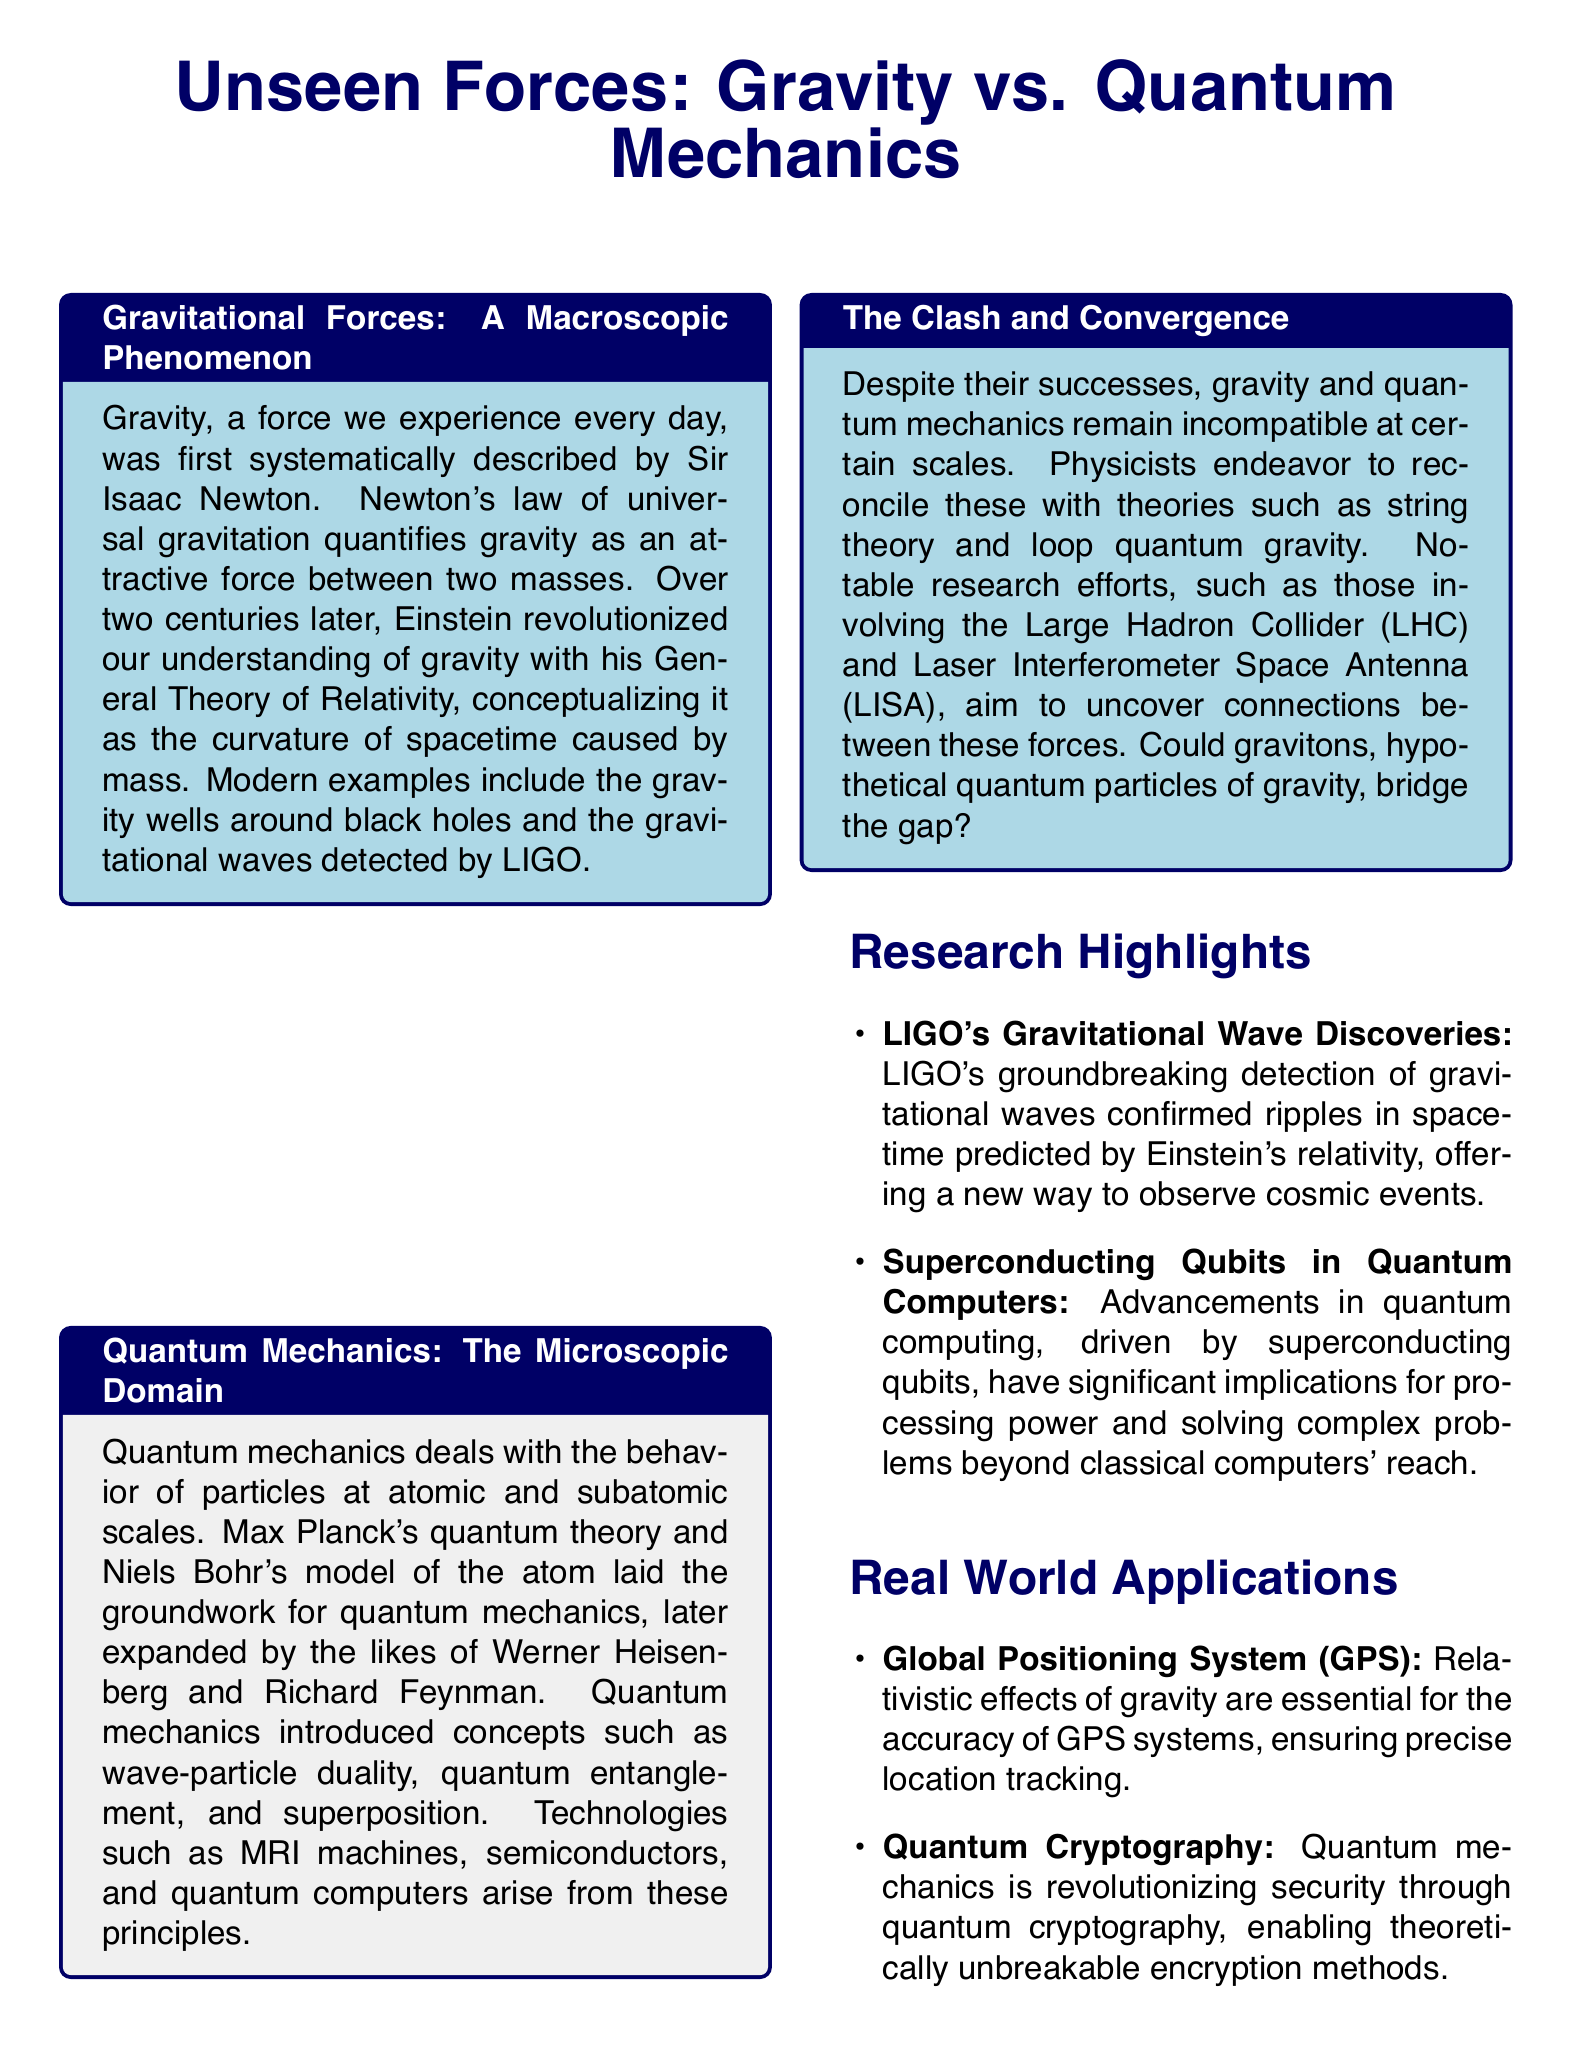What is the title of the article? The title of the article is prominently displayed at the top of the document, emphasizing the main topic discussed.
Answer: Unseen Forces: Gravity vs. Quantum Mechanics Who described gravity systematically? The document states that Sir Isaac Newton first described gravity systematically, giving credit to his work in this area.
Answer: Sir Isaac Newton What concept did Einstein revolutionize regarding gravity? The text explains that Einstein conceptualized gravity as the curvature of spacetime caused by mass, which was a significant shift from Newton's view.
Answer: Curvature of spacetime What technology arises from quantum mechanics? The document lists several technologies that have developed due to quantum mechanics; one example is mentioned specifically in the context of its applications.
Answer: MRI machines What kind of forces remain incompatible at certain scales? The document notes a specific clash in the understanding of forces that leads to theoretical challenges in physics.
Answer: Gravity and quantum mechanics What is a research effort mentioned for reconciling gravity and quantum mechanics? In the section concerning the clash and convergence of these fields, one specific research effort is highlighted for its significance in uncovering connections between forces.
Answer: Large Hadron Collider (LHC) What are the implications of gravitational waves according to LIGO? LIGO's discoveries are described in relation to a specific scientific phenomenon, showcasing the essentials of gravitational wave detection.
Answer: Ripples in spacetime What impact does quantum cryptography have on security? The document outlines the revolutionary effects of quantum mechanics specifically related to encryption methods and security.
Answer: Theoretically unbreakable encryption methods 